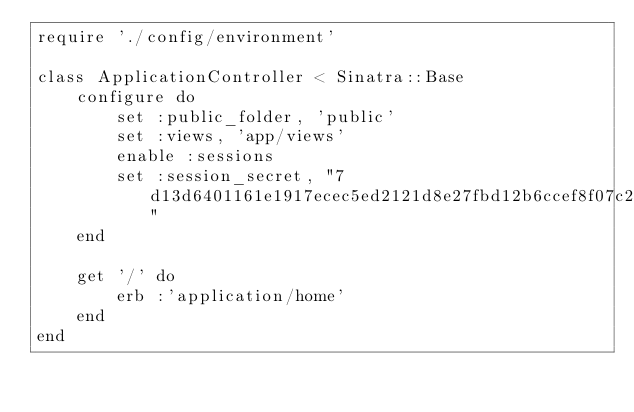<code> <loc_0><loc_0><loc_500><loc_500><_Ruby_>require './config/environment'

class ApplicationController < Sinatra::Base
    configure do 
        set :public_folder, 'public'
        set :views, 'app/views'
        enable :sessions
        set :session_secret, "7d13d6401161e1917ecec5ed2121d8e27fbd12b6ccef8f07c226b11b1e823e8732f9a34288f2dc86bf63d91957e09037b4b1d31bacee10c0ec2de0eae9b64ce9"
    end

    get '/' do
        erb :'application/home'
    end
end</code> 